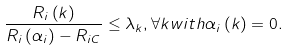<formula> <loc_0><loc_0><loc_500><loc_500>\frac { R _ { i } \left ( k \right ) } { R _ { i } \left ( \alpha _ { i } \right ) - R _ { i C } } \leq \lambda _ { k } , \forall k w i t h \alpha _ { i } \left ( k \right ) = 0 .</formula> 